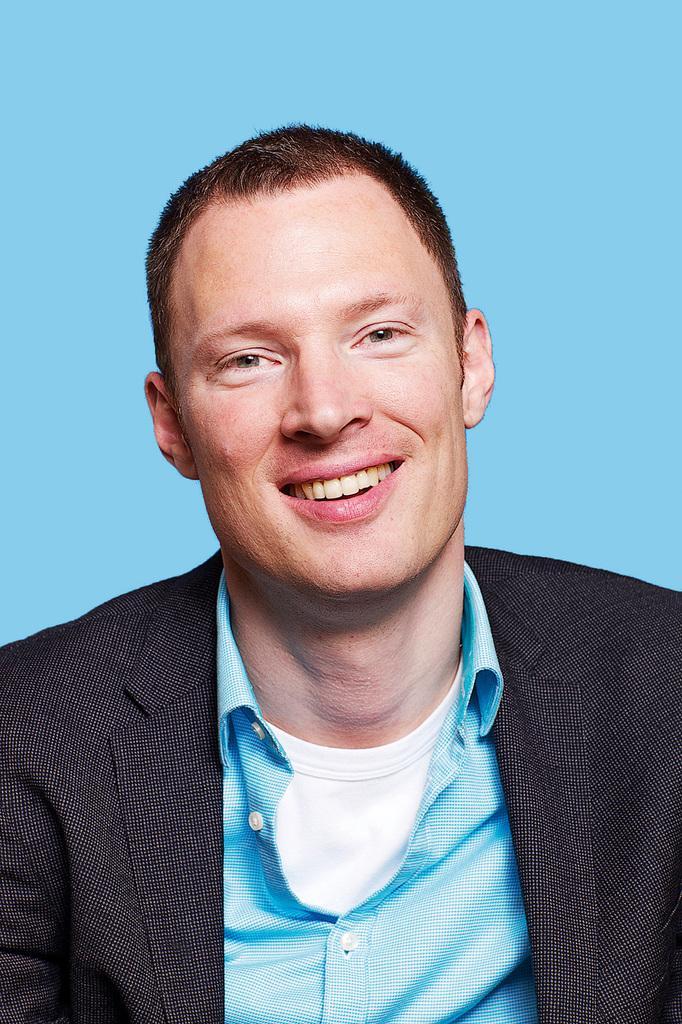Could you give a brief overview of what you see in this image? This image consists of a man wearing a black suit. He is also wearing a blue shirt. The background is blue in color. 